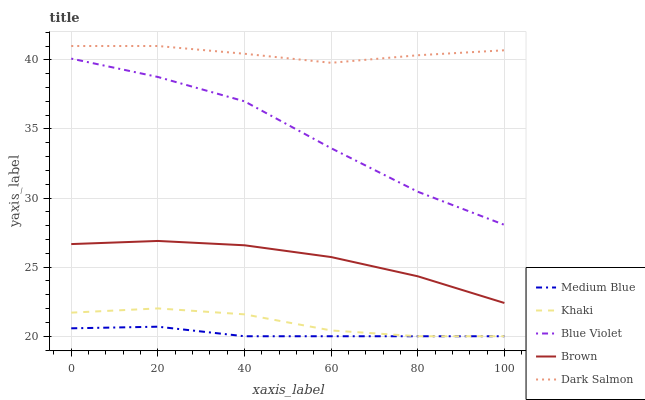Does Khaki have the minimum area under the curve?
Answer yes or no. No. Does Khaki have the maximum area under the curve?
Answer yes or no. No. Is Khaki the smoothest?
Answer yes or no. No. Is Khaki the roughest?
Answer yes or no. No. Does Dark Salmon have the lowest value?
Answer yes or no. No. Does Khaki have the highest value?
Answer yes or no. No. Is Khaki less than Brown?
Answer yes or no. Yes. Is Dark Salmon greater than Khaki?
Answer yes or no. Yes. Does Khaki intersect Brown?
Answer yes or no. No. 